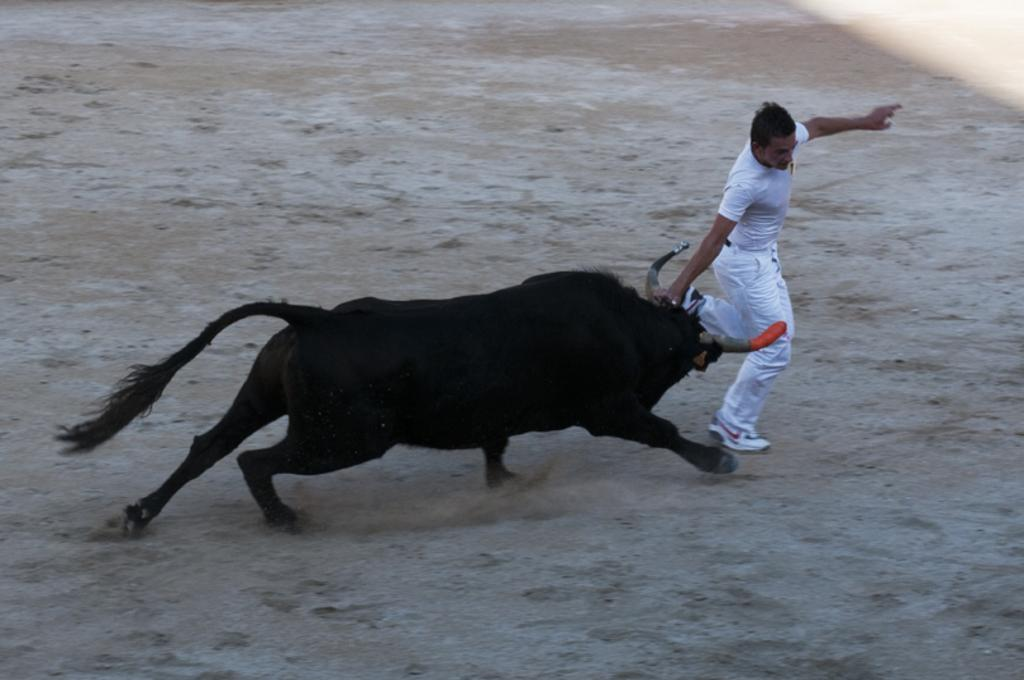What animal is present in the image? There is a bull in the image. Who else is present in the image? There is a person in the image. What is the person wearing? The person is wearing a white dress. What type of footwear is the person wearing? The person is wearing shoes. What are the person and the bull doing in the image? The person and the bull are running on the ground. Where is the bucket located in the image? There is no bucket present in the image. What type of stick is the person holding while running with the bull? There is no stick present in the image; the person is not holding anything. 